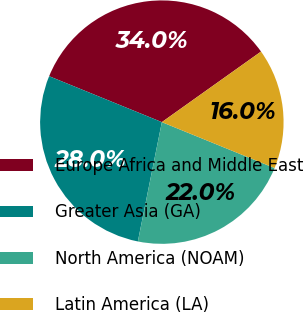Convert chart to OTSL. <chart><loc_0><loc_0><loc_500><loc_500><pie_chart><fcel>Europe Africa and Middle East<fcel>Greater Asia (GA)<fcel>North America (NOAM)<fcel>Latin America (LA)<nl><fcel>34.0%<fcel>28.0%<fcel>22.0%<fcel>16.0%<nl></chart> 